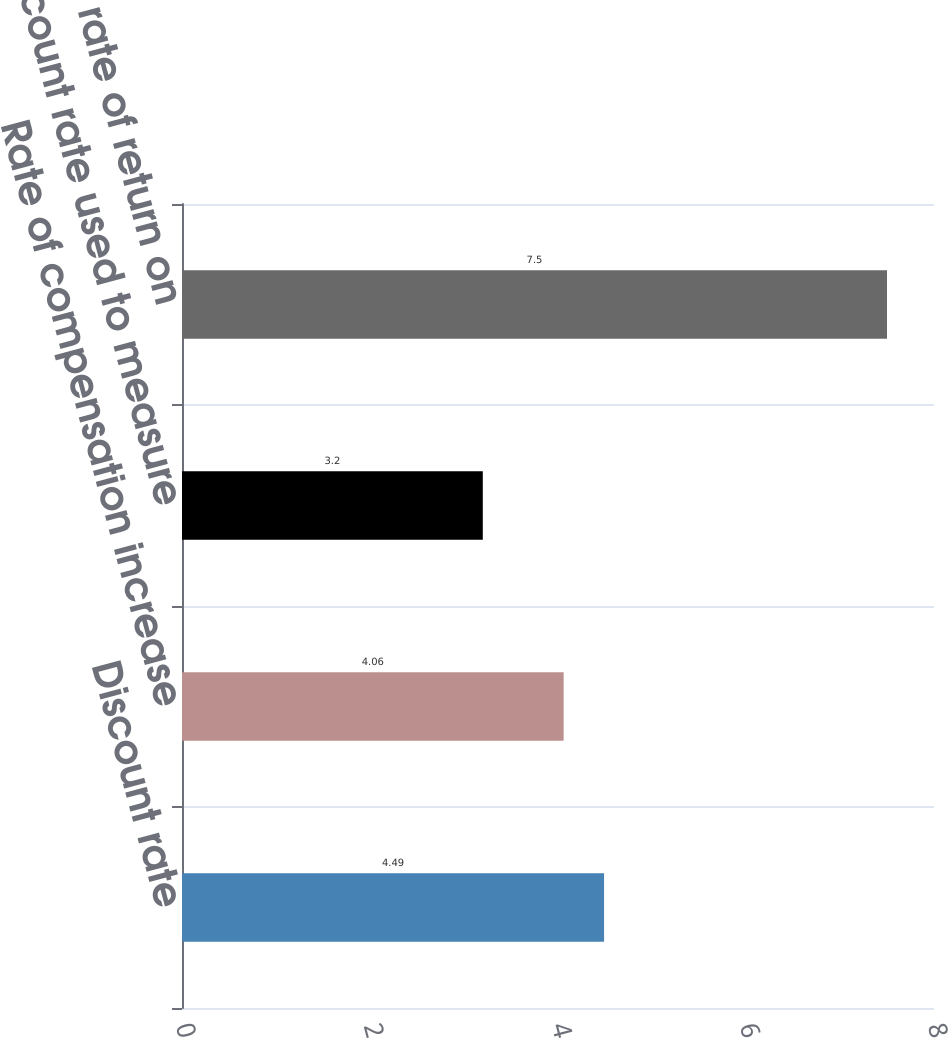Convert chart to OTSL. <chart><loc_0><loc_0><loc_500><loc_500><bar_chart><fcel>Discount rate<fcel>Rate of compensation increase<fcel>Discount rate used to measure<fcel>Expected rate of return on<nl><fcel>4.49<fcel>4.06<fcel>3.2<fcel>7.5<nl></chart> 